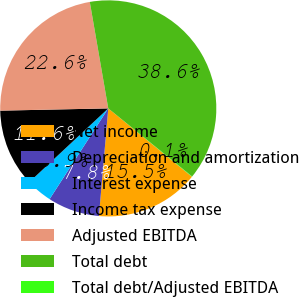<chart> <loc_0><loc_0><loc_500><loc_500><pie_chart><fcel>Net income<fcel>Depreciation and amortization<fcel>Interest expense<fcel>Income tax expense<fcel>Adjusted EBITDA<fcel>Total debt<fcel>Total debt/Adjusted EBITDA<nl><fcel>15.47%<fcel>7.76%<fcel>3.91%<fcel>11.62%<fcel>22.6%<fcel>38.59%<fcel>0.05%<nl></chart> 